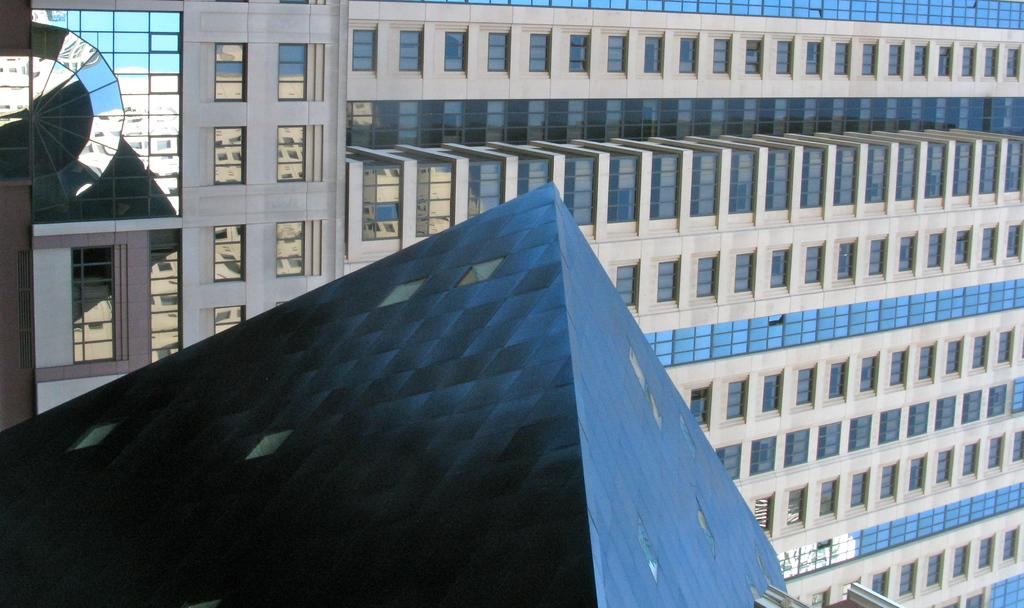What type of structure is visible in the image? There is a building in the image. What is on top of the building? The building has a roof. What type of windows are on the building? The building has glass windows. What type of locket is hanging from the roof of the building in the image? There is no locket hanging from the roof of the building in the image. How many cherries can be seen on the windows of the building? There are no cherries present on the windows of the building in the image. 